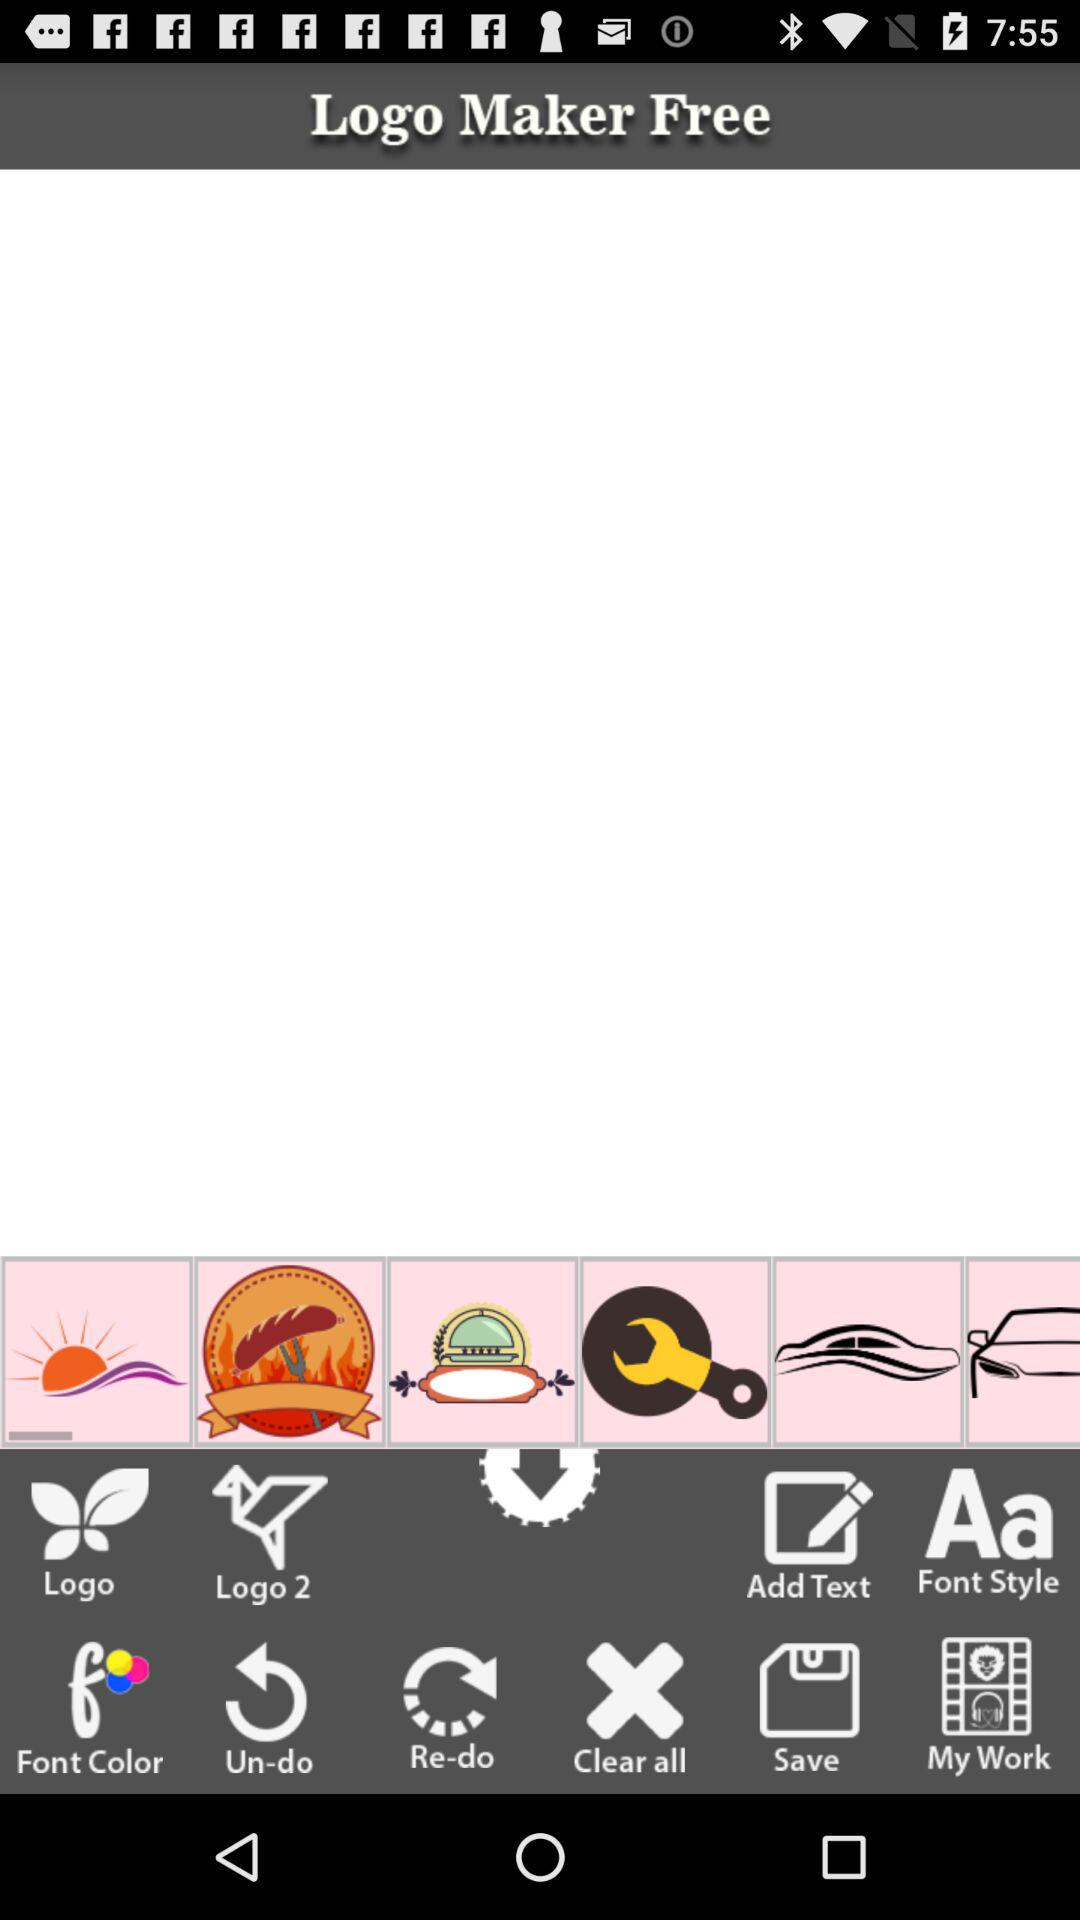What is the name of the application? The name of the application is "Logo Maker Free". 